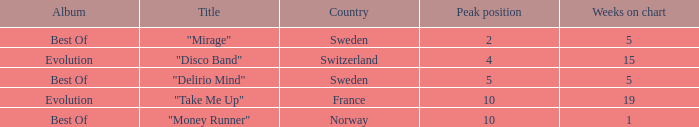What is the title of the single with the peak position of 10 and weeks on chart is less than 19? "Money Runner". 